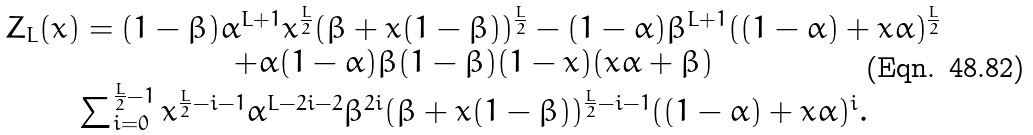Convert formula to latex. <formula><loc_0><loc_0><loc_500><loc_500>\begin{array} { c } Z _ { L } ( x ) = ( 1 - \beta ) \alpha ^ { L + 1 } x ^ { \frac { L } { 2 } } ( \beta + x ( 1 - \beta ) ) ^ { \frac { L } { 2 } } - ( 1 - \alpha ) \beta ^ { L + 1 } ( ( 1 - \alpha ) + x \alpha ) ^ { \frac { L } { 2 } } \\ + \alpha ( 1 - \alpha ) \beta ( 1 - \beta ) ( 1 - x ) ( x \alpha + \beta ) \\ \sum _ { i = 0 } ^ { \frac { L } { 2 } - 1 } x ^ { \frac { L } { 2 } - i - 1 } \alpha ^ { L - 2 i - 2 } \beta ^ { 2 i } ( \beta + x ( 1 - \beta ) ) ^ { \frac { L } { 2 } - i - 1 } ( ( 1 - \alpha ) + x \alpha ) ^ { i } . \end{array}</formula> 